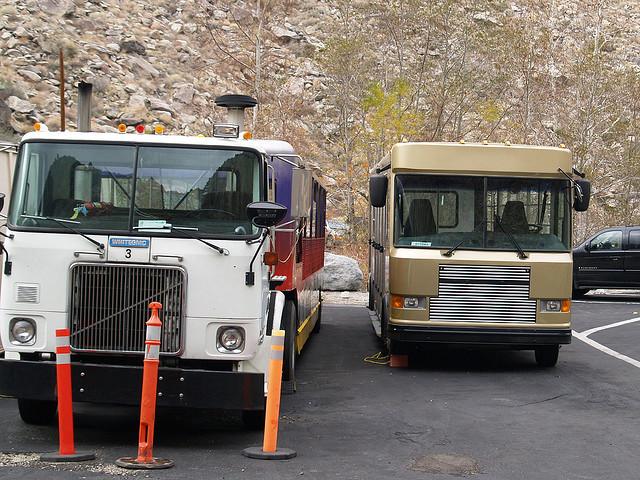How many traffic cones are there?
Be succinct. 3. Was this taken in a rural setting?
Keep it brief. Yes. Which van is closer to the camera?
Give a very brief answer. White one. 